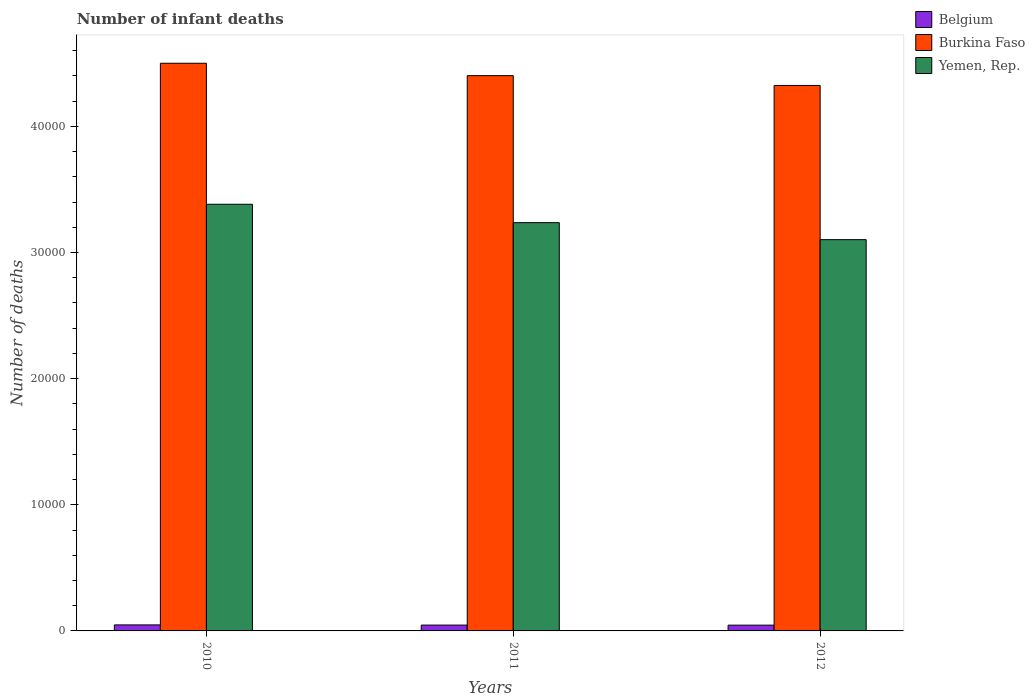Are the number of bars per tick equal to the number of legend labels?
Provide a succinct answer. Yes. How many bars are there on the 2nd tick from the right?
Offer a very short reply. 3. What is the number of infant deaths in Belgium in 2011?
Your answer should be compact. 462. Across all years, what is the maximum number of infant deaths in Burkina Faso?
Your answer should be very brief. 4.50e+04. Across all years, what is the minimum number of infant deaths in Yemen, Rep.?
Your answer should be compact. 3.10e+04. In which year was the number of infant deaths in Belgium minimum?
Your response must be concise. 2012. What is the total number of infant deaths in Belgium in the graph?
Give a very brief answer. 1396. What is the difference between the number of infant deaths in Belgium in 2011 and that in 2012?
Ensure brevity in your answer.  5. What is the difference between the number of infant deaths in Burkina Faso in 2011 and the number of infant deaths in Belgium in 2012?
Provide a short and direct response. 4.36e+04. What is the average number of infant deaths in Yemen, Rep. per year?
Make the answer very short. 3.24e+04. In the year 2011, what is the difference between the number of infant deaths in Belgium and number of infant deaths in Yemen, Rep.?
Offer a terse response. -3.19e+04. In how many years, is the number of infant deaths in Belgium greater than 12000?
Offer a terse response. 0. What is the ratio of the number of infant deaths in Burkina Faso in 2010 to that in 2012?
Give a very brief answer. 1.04. Is the difference between the number of infant deaths in Belgium in 2010 and 2011 greater than the difference between the number of infant deaths in Yemen, Rep. in 2010 and 2011?
Your answer should be very brief. No. What is the difference between the highest and the second highest number of infant deaths in Belgium?
Offer a very short reply. 15. What is the difference between the highest and the lowest number of infant deaths in Belgium?
Your answer should be very brief. 20. What does the 1st bar from the left in 2011 represents?
Make the answer very short. Belgium. Are all the bars in the graph horizontal?
Your answer should be very brief. No. How many years are there in the graph?
Your answer should be very brief. 3. What is the difference between two consecutive major ticks on the Y-axis?
Your response must be concise. 10000. Does the graph contain grids?
Your answer should be very brief. No. How are the legend labels stacked?
Make the answer very short. Vertical. What is the title of the graph?
Ensure brevity in your answer.  Number of infant deaths. Does "Malaysia" appear as one of the legend labels in the graph?
Keep it short and to the point. No. What is the label or title of the X-axis?
Keep it short and to the point. Years. What is the label or title of the Y-axis?
Your answer should be compact. Number of deaths. What is the Number of deaths in Belgium in 2010?
Make the answer very short. 477. What is the Number of deaths in Burkina Faso in 2010?
Make the answer very short. 4.50e+04. What is the Number of deaths of Yemen, Rep. in 2010?
Provide a succinct answer. 3.38e+04. What is the Number of deaths of Belgium in 2011?
Keep it short and to the point. 462. What is the Number of deaths in Burkina Faso in 2011?
Give a very brief answer. 4.40e+04. What is the Number of deaths of Yemen, Rep. in 2011?
Your response must be concise. 3.24e+04. What is the Number of deaths of Belgium in 2012?
Your answer should be very brief. 457. What is the Number of deaths of Burkina Faso in 2012?
Give a very brief answer. 4.32e+04. What is the Number of deaths of Yemen, Rep. in 2012?
Your response must be concise. 3.10e+04. Across all years, what is the maximum Number of deaths of Belgium?
Provide a succinct answer. 477. Across all years, what is the maximum Number of deaths of Burkina Faso?
Offer a very short reply. 4.50e+04. Across all years, what is the maximum Number of deaths of Yemen, Rep.?
Keep it short and to the point. 3.38e+04. Across all years, what is the minimum Number of deaths in Belgium?
Your response must be concise. 457. Across all years, what is the minimum Number of deaths in Burkina Faso?
Your response must be concise. 4.32e+04. Across all years, what is the minimum Number of deaths in Yemen, Rep.?
Ensure brevity in your answer.  3.10e+04. What is the total Number of deaths of Belgium in the graph?
Offer a very short reply. 1396. What is the total Number of deaths in Burkina Faso in the graph?
Offer a very short reply. 1.32e+05. What is the total Number of deaths of Yemen, Rep. in the graph?
Offer a very short reply. 9.72e+04. What is the difference between the Number of deaths of Burkina Faso in 2010 and that in 2011?
Make the answer very short. 982. What is the difference between the Number of deaths in Yemen, Rep. in 2010 and that in 2011?
Your answer should be very brief. 1457. What is the difference between the Number of deaths of Belgium in 2010 and that in 2012?
Ensure brevity in your answer.  20. What is the difference between the Number of deaths of Burkina Faso in 2010 and that in 2012?
Give a very brief answer. 1759. What is the difference between the Number of deaths of Yemen, Rep. in 2010 and that in 2012?
Ensure brevity in your answer.  2805. What is the difference between the Number of deaths of Burkina Faso in 2011 and that in 2012?
Your answer should be compact. 777. What is the difference between the Number of deaths of Yemen, Rep. in 2011 and that in 2012?
Your answer should be very brief. 1348. What is the difference between the Number of deaths in Belgium in 2010 and the Number of deaths in Burkina Faso in 2011?
Keep it short and to the point. -4.35e+04. What is the difference between the Number of deaths of Belgium in 2010 and the Number of deaths of Yemen, Rep. in 2011?
Make the answer very short. -3.19e+04. What is the difference between the Number of deaths in Burkina Faso in 2010 and the Number of deaths in Yemen, Rep. in 2011?
Your answer should be very brief. 1.26e+04. What is the difference between the Number of deaths in Belgium in 2010 and the Number of deaths in Burkina Faso in 2012?
Offer a very short reply. -4.28e+04. What is the difference between the Number of deaths in Belgium in 2010 and the Number of deaths in Yemen, Rep. in 2012?
Keep it short and to the point. -3.05e+04. What is the difference between the Number of deaths in Burkina Faso in 2010 and the Number of deaths in Yemen, Rep. in 2012?
Provide a succinct answer. 1.40e+04. What is the difference between the Number of deaths in Belgium in 2011 and the Number of deaths in Burkina Faso in 2012?
Offer a terse response. -4.28e+04. What is the difference between the Number of deaths in Belgium in 2011 and the Number of deaths in Yemen, Rep. in 2012?
Provide a short and direct response. -3.06e+04. What is the difference between the Number of deaths of Burkina Faso in 2011 and the Number of deaths of Yemen, Rep. in 2012?
Offer a terse response. 1.30e+04. What is the average Number of deaths in Belgium per year?
Offer a terse response. 465.33. What is the average Number of deaths in Burkina Faso per year?
Offer a terse response. 4.41e+04. What is the average Number of deaths in Yemen, Rep. per year?
Ensure brevity in your answer.  3.24e+04. In the year 2010, what is the difference between the Number of deaths in Belgium and Number of deaths in Burkina Faso?
Your answer should be compact. -4.45e+04. In the year 2010, what is the difference between the Number of deaths in Belgium and Number of deaths in Yemen, Rep.?
Provide a succinct answer. -3.33e+04. In the year 2010, what is the difference between the Number of deaths in Burkina Faso and Number of deaths in Yemen, Rep.?
Ensure brevity in your answer.  1.12e+04. In the year 2011, what is the difference between the Number of deaths of Belgium and Number of deaths of Burkina Faso?
Ensure brevity in your answer.  -4.36e+04. In the year 2011, what is the difference between the Number of deaths in Belgium and Number of deaths in Yemen, Rep.?
Provide a succinct answer. -3.19e+04. In the year 2011, what is the difference between the Number of deaths in Burkina Faso and Number of deaths in Yemen, Rep.?
Your response must be concise. 1.17e+04. In the year 2012, what is the difference between the Number of deaths in Belgium and Number of deaths in Burkina Faso?
Keep it short and to the point. -4.28e+04. In the year 2012, what is the difference between the Number of deaths in Belgium and Number of deaths in Yemen, Rep.?
Give a very brief answer. -3.06e+04. In the year 2012, what is the difference between the Number of deaths of Burkina Faso and Number of deaths of Yemen, Rep.?
Make the answer very short. 1.22e+04. What is the ratio of the Number of deaths in Belgium in 2010 to that in 2011?
Offer a very short reply. 1.03. What is the ratio of the Number of deaths of Burkina Faso in 2010 to that in 2011?
Your response must be concise. 1.02. What is the ratio of the Number of deaths of Yemen, Rep. in 2010 to that in 2011?
Your answer should be compact. 1.04. What is the ratio of the Number of deaths of Belgium in 2010 to that in 2012?
Make the answer very short. 1.04. What is the ratio of the Number of deaths of Burkina Faso in 2010 to that in 2012?
Make the answer very short. 1.04. What is the ratio of the Number of deaths in Yemen, Rep. in 2010 to that in 2012?
Make the answer very short. 1.09. What is the ratio of the Number of deaths in Belgium in 2011 to that in 2012?
Offer a terse response. 1.01. What is the ratio of the Number of deaths in Yemen, Rep. in 2011 to that in 2012?
Provide a short and direct response. 1.04. What is the difference between the highest and the second highest Number of deaths in Burkina Faso?
Provide a short and direct response. 982. What is the difference between the highest and the second highest Number of deaths of Yemen, Rep.?
Provide a succinct answer. 1457. What is the difference between the highest and the lowest Number of deaths in Burkina Faso?
Your answer should be compact. 1759. What is the difference between the highest and the lowest Number of deaths of Yemen, Rep.?
Your answer should be compact. 2805. 